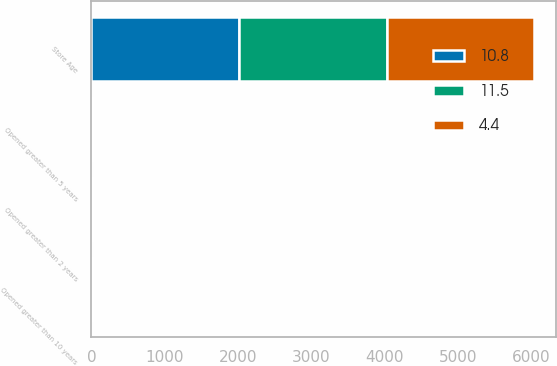Convert chart to OTSL. <chart><loc_0><loc_0><loc_500><loc_500><stacked_bar_chart><ecel><fcel>Store Age<fcel>Opened greater than 10 years<fcel>Opened greater than 5 years<fcel>Opened greater than 2 years<nl><fcel>4.4<fcel>2014<fcel>10.5<fcel>10.9<fcel>11.5<nl><fcel>11.5<fcel>2013<fcel>2.1<fcel>3.6<fcel>4.4<nl><fcel>10.8<fcel>2012<fcel>8.1<fcel>9.8<fcel>10.8<nl></chart> 